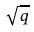Convert formula to latex. <formula><loc_0><loc_0><loc_500><loc_500>\sqrt { q }</formula> 